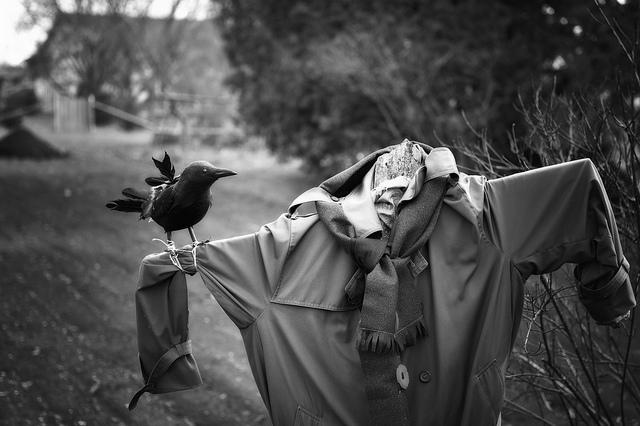How many white buttons are there?
Quick response, please. 1. What is the bird perched on?
Concise answer only. Scarecrow. Is this black and white?
Quick response, please. Yes. 